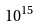Convert formula to latex. <formula><loc_0><loc_0><loc_500><loc_500>1 0 ^ { 1 5 }</formula> 